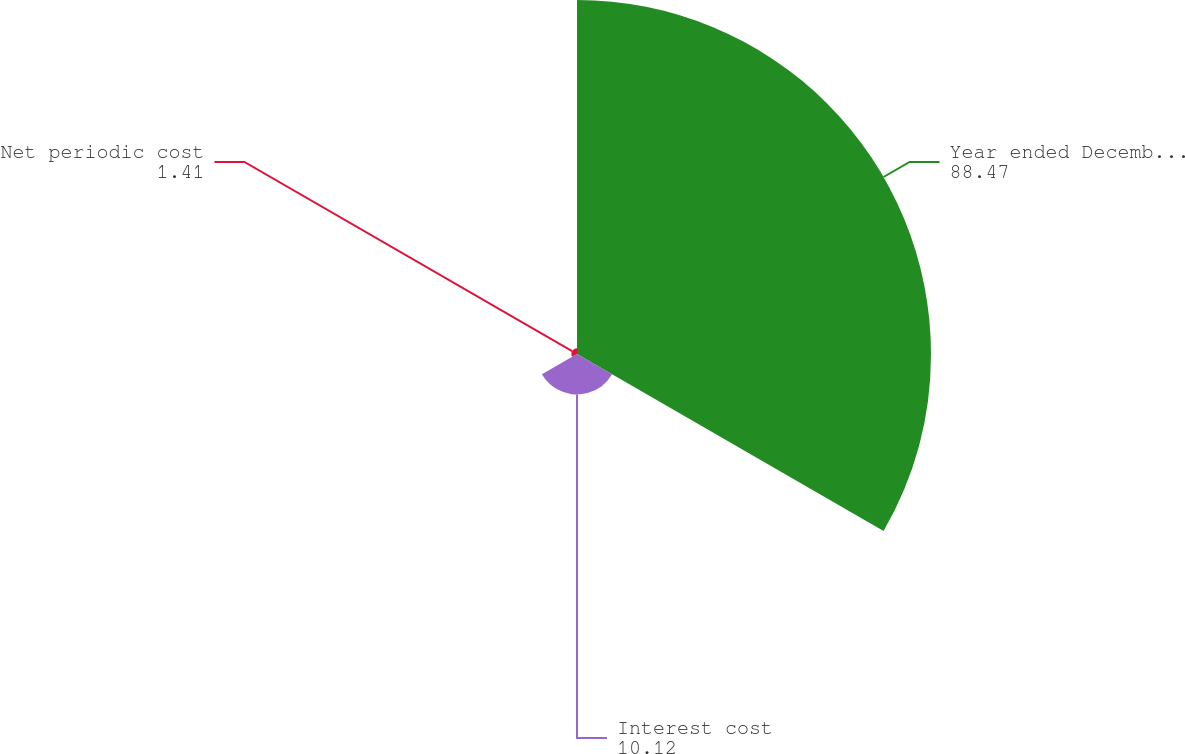Convert chart. <chart><loc_0><loc_0><loc_500><loc_500><pie_chart><fcel>Year ended December 31 - in<fcel>Interest cost<fcel>Net periodic cost<nl><fcel>88.47%<fcel>10.12%<fcel>1.41%<nl></chart> 